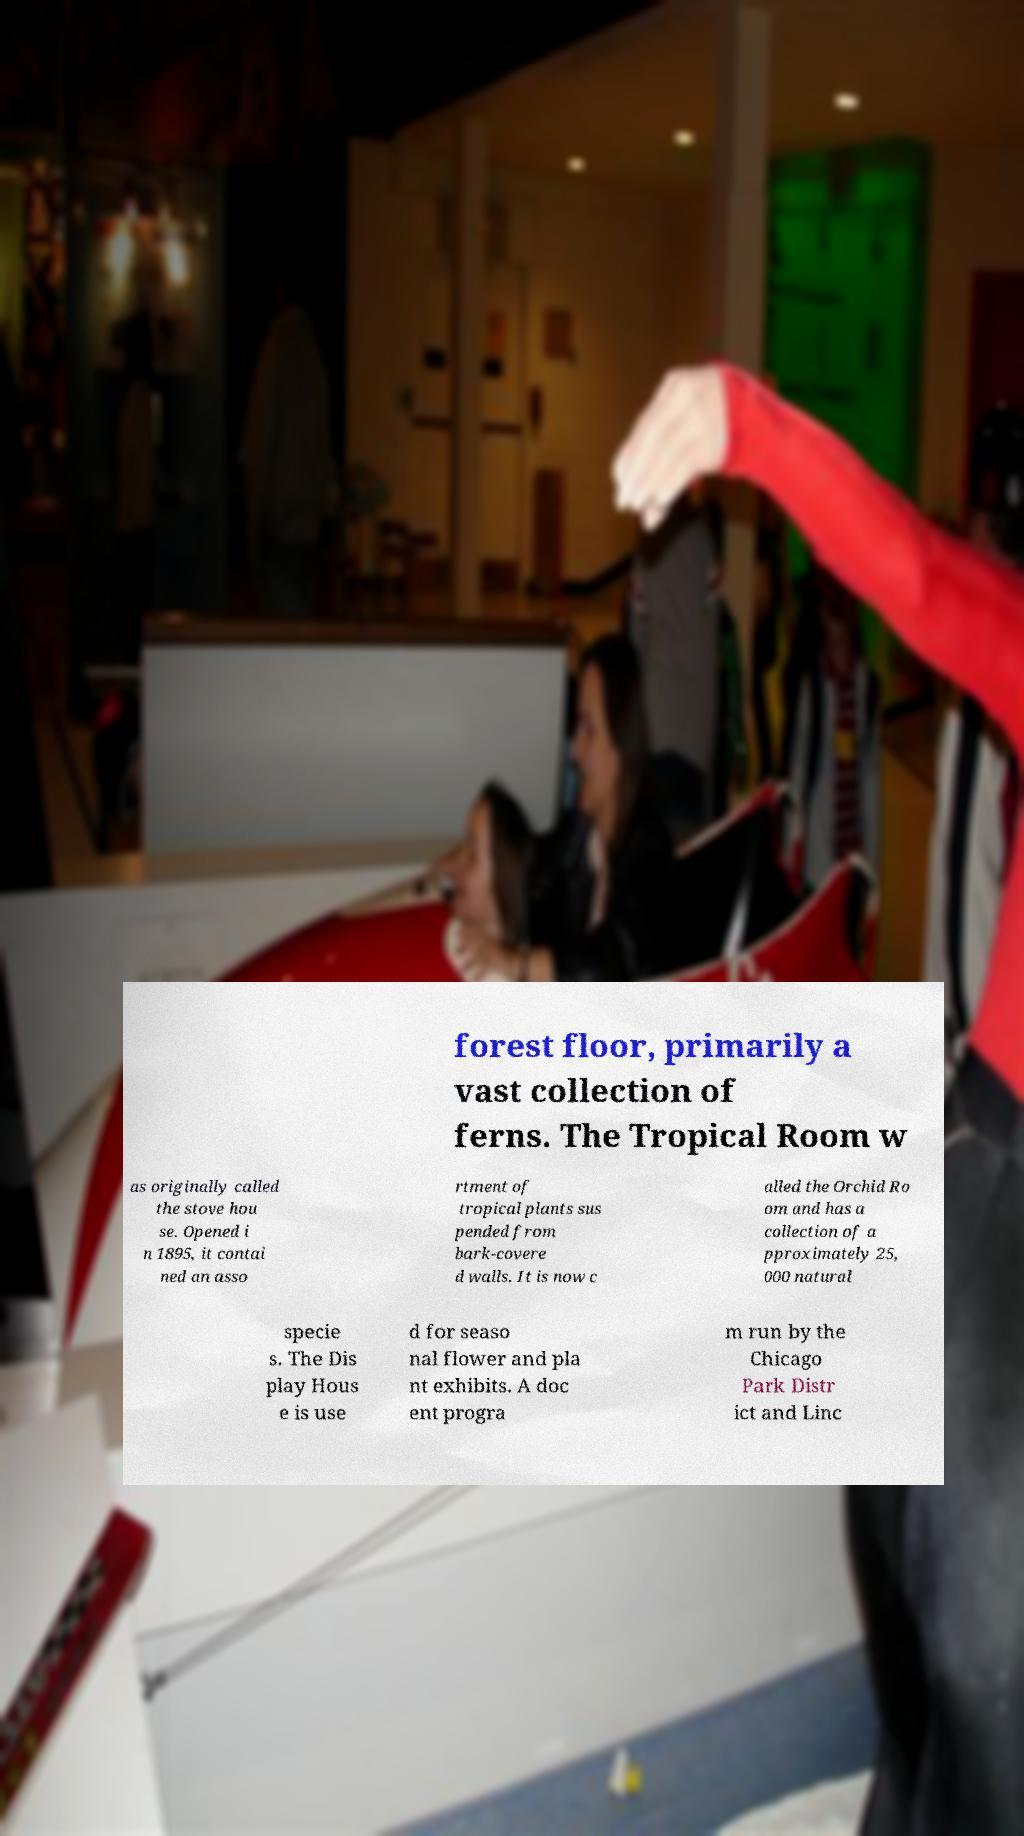Could you assist in decoding the text presented in this image and type it out clearly? forest floor, primarily a vast collection of ferns. The Tropical Room w as originally called the stove hou se. Opened i n 1895, it contai ned an asso rtment of tropical plants sus pended from bark-covere d walls. It is now c alled the Orchid Ro om and has a collection of a pproximately 25, 000 natural specie s. The Dis play Hous e is use d for seaso nal flower and pla nt exhibits. A doc ent progra m run by the Chicago Park Distr ict and Linc 